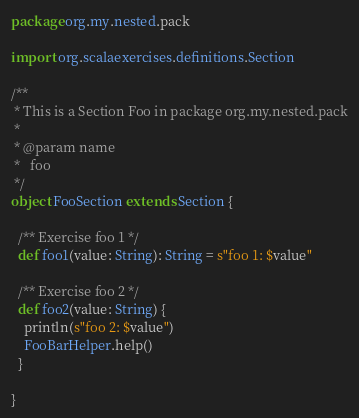Convert code to text. <code><loc_0><loc_0><loc_500><loc_500><_Scala_>package org.my.nested.pack

import org.scalaexercises.definitions.Section

/**
 * This is a Section Foo in package org.my.nested.pack
 *
 * @param name
 *   foo
 */
object FooSection extends Section {

  /** Exercise foo 1 */
  def foo1(value: String): String = s"foo 1: $value"

  /** Exercise foo 2 */
  def foo2(value: String) {
    println(s"foo 2: $value")
    FooBarHelper.help()
  }

}
</code> 